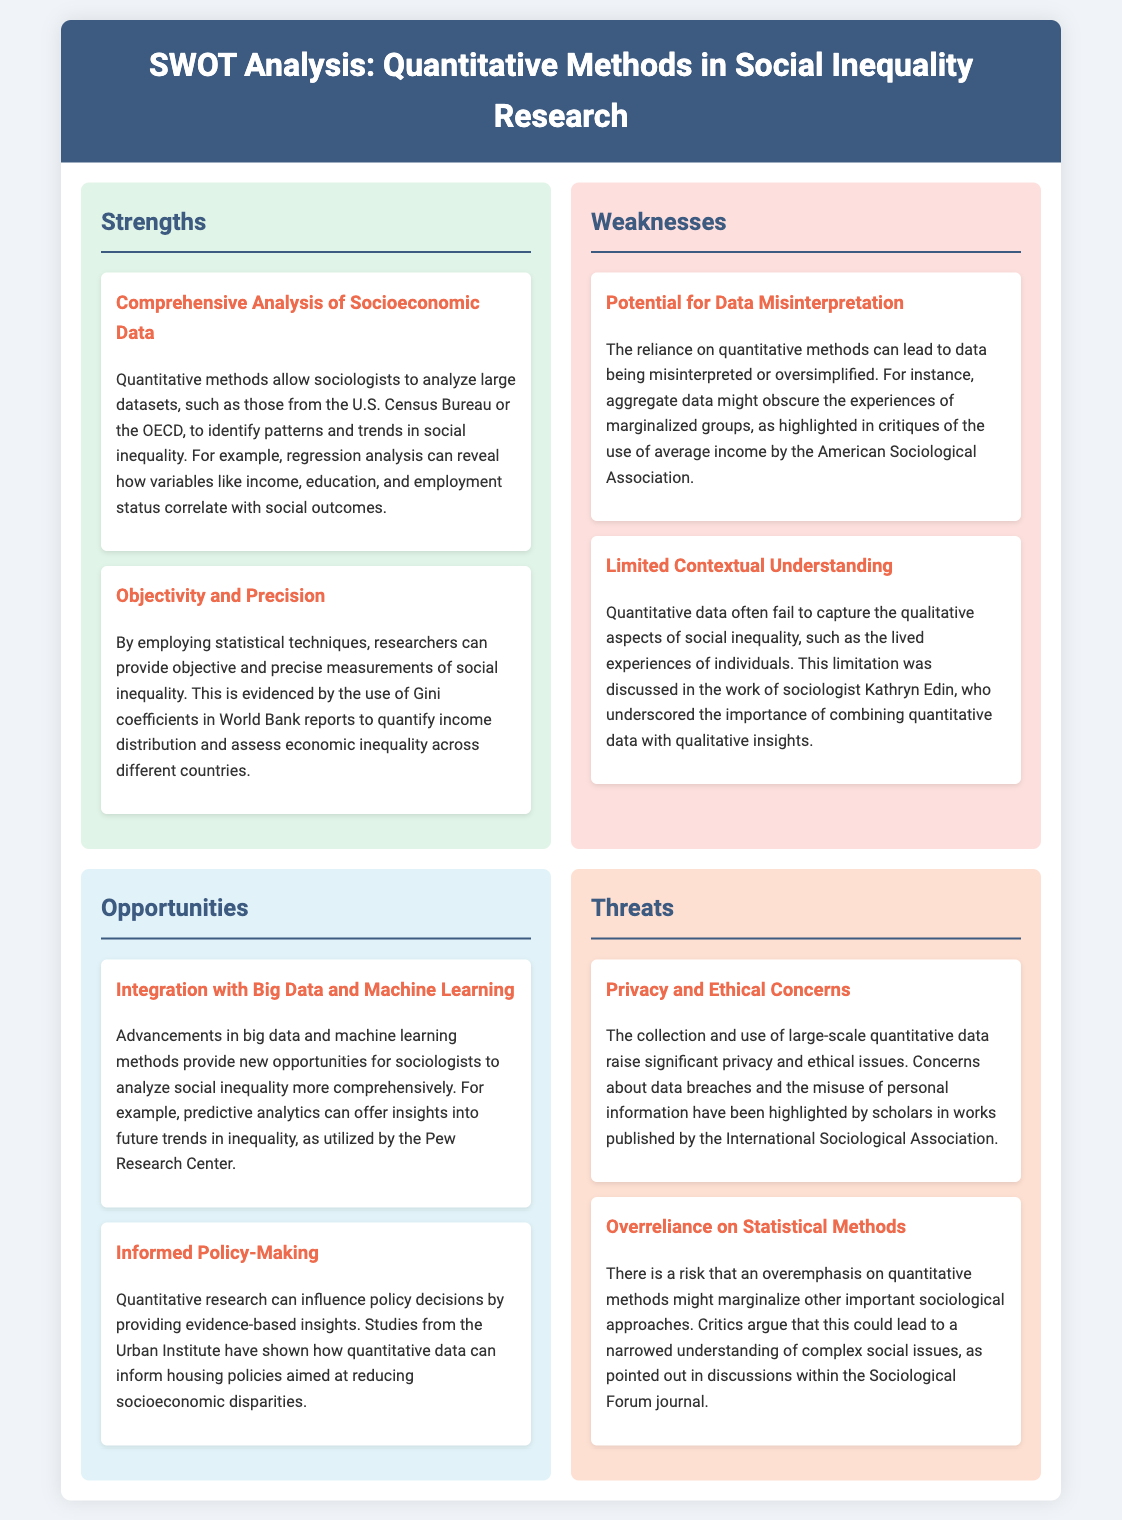What are two strengths of quantitative methods? The strengths listed include comprehensive analysis of socioeconomic data and objectivity and precision.
Answer: Comprehensive analysis of socioeconomic data, objectivity and precision What is one weakness related to data interpretation? The document mentions that the reliance on quantitative methods can lead to data being misinterpreted or oversimplified.
Answer: Potential for data misinterpretation What opportunity is mentioned for analyzing social inequality? The analysis highlights integration with big data and machine learning as an opportunity.
Answer: Integration with big data and machine learning What ethical concern is raised regarding quantitative data? The document specifies privacy and ethical concerns as significant issues related to the collection and use of quantitative data.
Answer: Privacy and ethical concerns Which organization is mentioned as utilizing predictive analytics? The Pew Research Center is cited for applying predictive analytics in their research.
Answer: Pew Research Center What is the primary theme of the threats section? The threats section discusses privacy and ethical concerns and the overreliance on statistical methods.
Answer: Privacy and ethical concerns, overreliance on statistical methods How can quantitative research influence policy? The document states that quantitative research can provide evidence-based insights for informing policy decisions.
Answer: Informed policy-making What method is used to measure economic inequality according to the document? The Gini coefficient is mentioned as a method for quantifying income distribution and assessing economic inequality.
Answer: Gini coefficients 